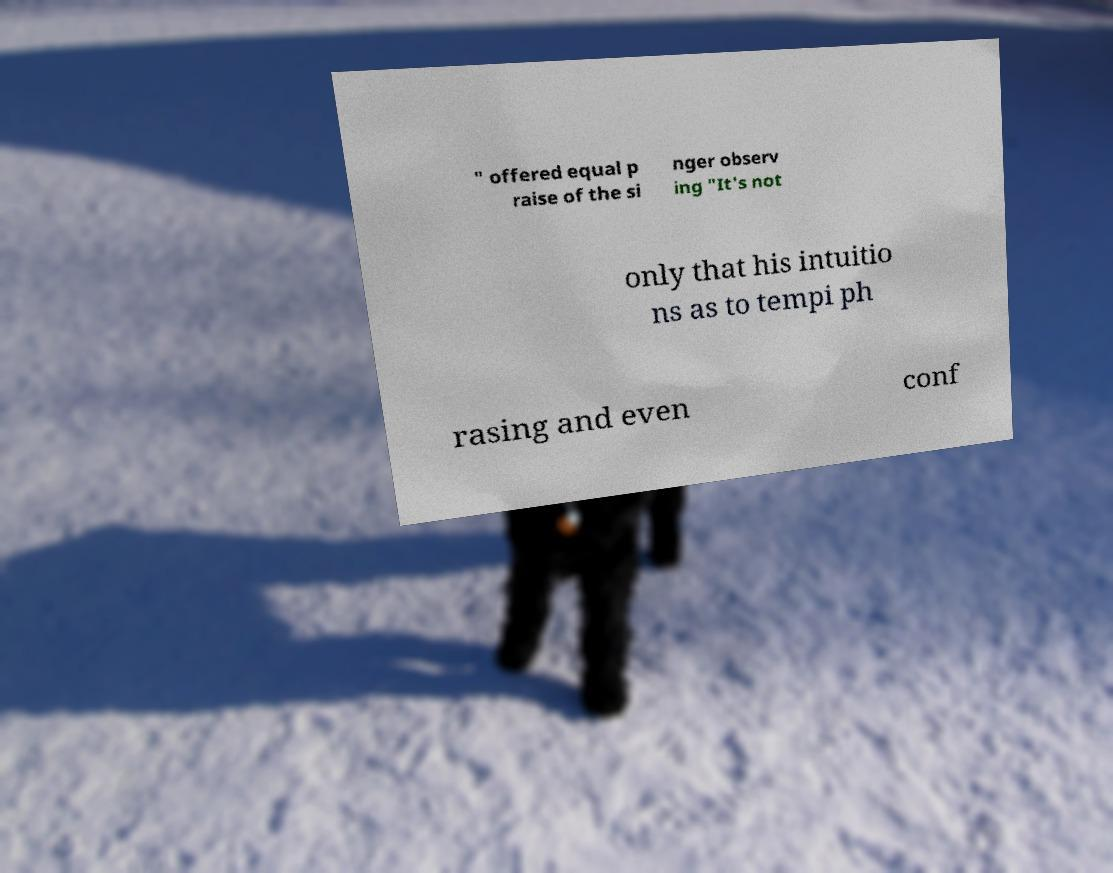Could you assist in decoding the text presented in this image and type it out clearly? " offered equal p raise of the si nger observ ing "It's not only that his intuitio ns as to tempi ph rasing and even conf 